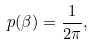<formula> <loc_0><loc_0><loc_500><loc_500>p ( \beta ) = \frac { 1 } { 2 \pi } ,</formula> 